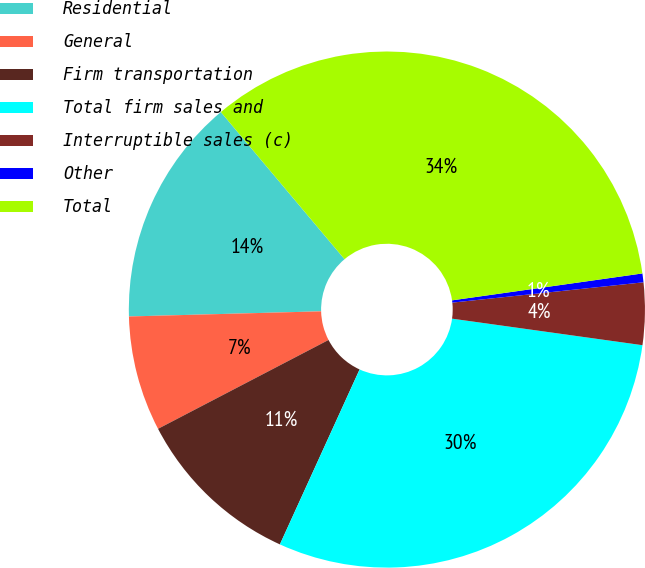<chart> <loc_0><loc_0><loc_500><loc_500><pie_chart><fcel>Residential<fcel>General<fcel>Firm transportation<fcel>Total firm sales and<fcel>Interruptible sales (c)<fcel>Other<fcel>Total<nl><fcel>14.3%<fcel>7.22%<fcel>10.55%<fcel>29.6%<fcel>3.89%<fcel>0.55%<fcel>33.89%<nl></chart> 